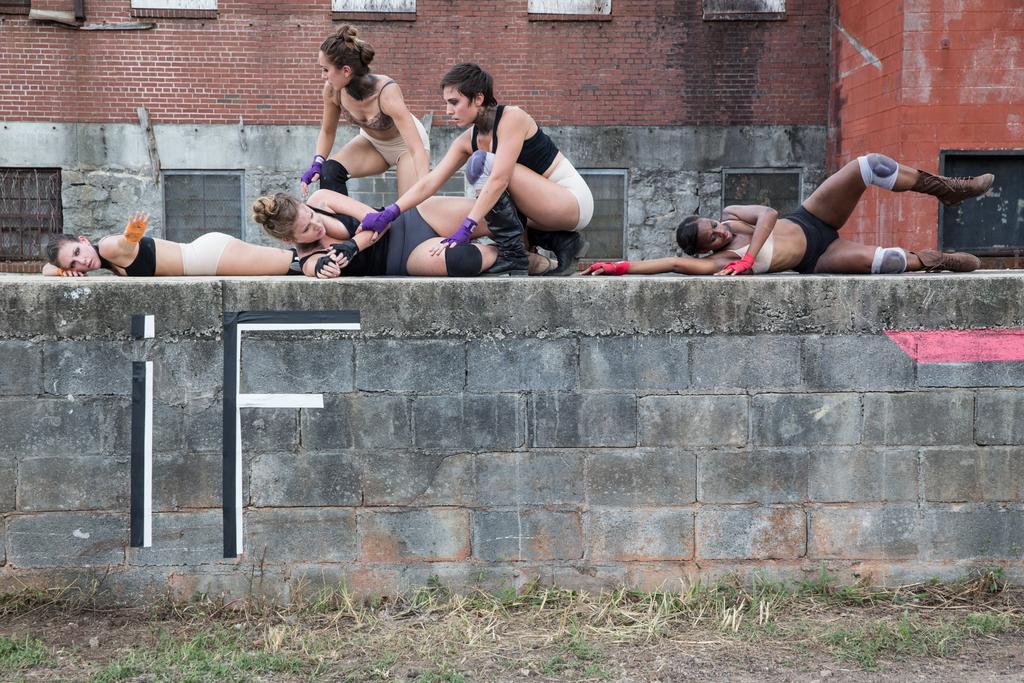Could you give a brief overview of what you see in this image? This image is taken outdoors. At the bottom of the image there is a ground with grass on it. In the middle of the image a few women are doing exercises on the wall. In the background there is a building with a few walls, windows, grills and a door. 